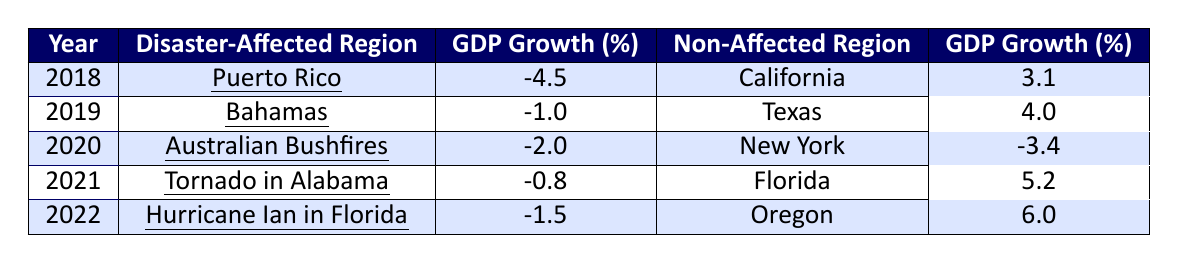What was the GDP growth of Puerto Rico in 2018? Puerto Rico is listed in the row for the year 2018, and its GDP growth is shown as -4.5%.
Answer: -4.5% Which region had a higher GDP growth in 2022: the disaster-affected region or the non-affected region? The disaster-affected region in 2022 was Hurricane Ian in Florida with a GDP growth of -1.5%, while the non-affected region, Oregon, had a GDP growth of 6.0%. Comparing these values, Oregon had a higher GDP growth.
Answer: Non-affected region What was the difference in GDP growth between the Bahamas in 2019 and Texas in the same year? In 2019, the GDP growth for the Bahamas was -1.0% and for Texas was 4.0%. The difference is calculated as 4.0% - (-1.0%) = 4.0% + 1.0% = 5.0%.
Answer: 5.0% In which year did the disaster-affected region show the least negative GDP growth? The least negative GDP growth for the disaster-affected regions can be found in the row for 2021, which shows -0.8% for the Tornado in Alabama. This is the least negative value compared to the other years.
Answer: 2021 What is the average GDP growth of all disaster-affected regions from 2018 to 2022? The GDP growth values for the disaster-affected regions are -4.5%, -1.0%, -2.0%, -0.8%, and -1.5%. To find the average, sum these values: (-4.5) + (-1.0) + (-2.0) + (-0.8) + (-1.5) = -11.8, then divide by the number of years (5), giving us -11.8 / 5 = -2.36%.
Answer: -2.36% Was the GDP growth for California in 2018 higher than that for New York in 2020? In 2018, California had a GDP growth of 3.1%, while New York had a GDP growth of -3.4% in 2020. Since 3.1% is greater than -3.4%, California's growth was indeed higher.
Answer: Yes Which disaster-affected region had a better GDP growth rate, Tornado in Alabama in 2021 or Hurricane Ian in Florida in 2022? The GDP growth for the Tornado in Alabama in 2021 was -0.8% and for Hurricane Ian in Florida in 2022 it was -1.5%. Since -0.8% is higher (less negative) than -1.5%, the Tornado in Alabama had a better GDP growth rate.
Answer: Tornado in Alabama What was the combined GDP growth of Texas and Oregon across the years presented? Texas had a GDP growth of 4.0% in 2019 and Oregon had 6.0% in 2022. Combining these values gives us 4.0% + 6.0% = 10.0%.
Answer: 10.0% 